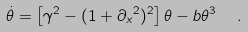<formula> <loc_0><loc_0><loc_500><loc_500>\dot { \theta } = \left [ \gamma ^ { 2 } - ( 1 + { \partial _ { x } } ^ { 2 } ) ^ { 2 } \right ] \theta - b \theta ^ { 3 } \ \ .</formula> 